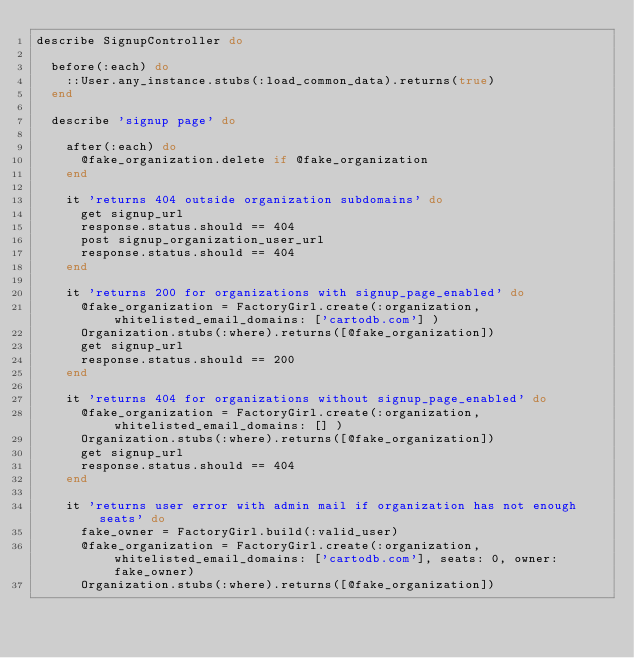<code> <loc_0><loc_0><loc_500><loc_500><_Ruby_>describe SignupController do

  before(:each) do
    ::User.any_instance.stubs(:load_common_data).returns(true)
  end

  describe 'signup page' do

    after(:each) do
      @fake_organization.delete if @fake_organization
    end

    it 'returns 404 outside organization subdomains' do
      get signup_url
      response.status.should == 404
      post signup_organization_user_url
      response.status.should == 404
    end

    it 'returns 200 for organizations with signup_page_enabled' do
      @fake_organization = FactoryGirl.create(:organization, whitelisted_email_domains: ['cartodb.com'] )
      Organization.stubs(:where).returns([@fake_organization])
      get signup_url
      response.status.should == 200
    end

    it 'returns 404 for organizations without signup_page_enabled' do
      @fake_organization = FactoryGirl.create(:organization, whitelisted_email_domains: [] )
      Organization.stubs(:where).returns([@fake_organization])
      get signup_url
      response.status.should == 404
    end

    it 'returns user error with admin mail if organization has not enough seats' do
      fake_owner = FactoryGirl.build(:valid_user)
      @fake_organization = FactoryGirl.create(:organization, whitelisted_email_domains: ['cartodb.com'], seats: 0, owner: fake_owner)
      Organization.stubs(:where).returns([@fake_organization])</code> 